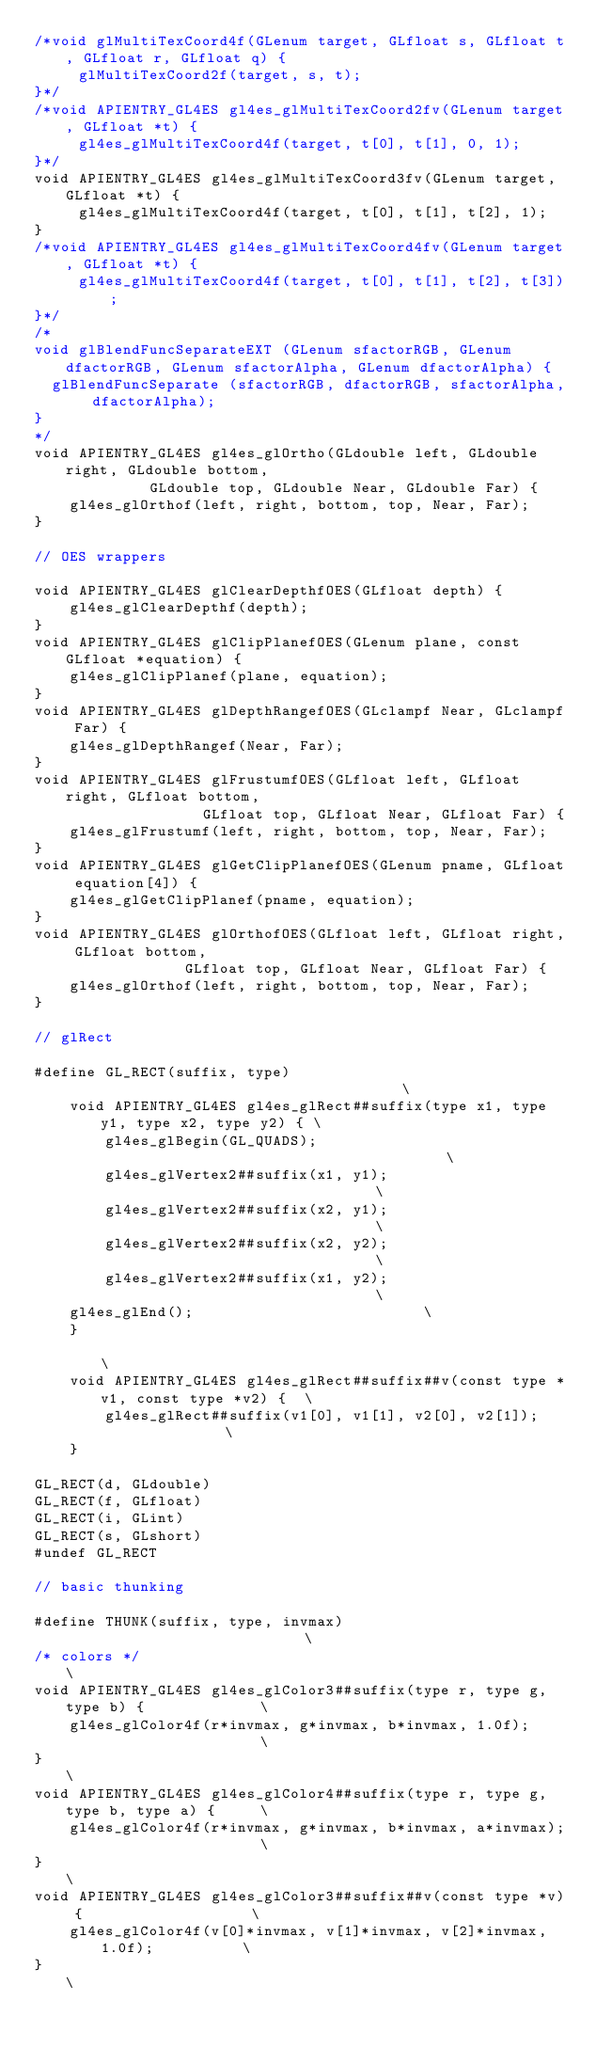<code> <loc_0><loc_0><loc_500><loc_500><_C_>/*void glMultiTexCoord4f(GLenum target, GLfloat s, GLfloat t, GLfloat r, GLfloat q) {
     glMultiTexCoord2f(target, s, t);
}*/
/*void APIENTRY_GL4ES gl4es_glMultiTexCoord2fv(GLenum target, GLfloat *t) {
     gl4es_glMultiTexCoord4f(target, t[0], t[1], 0, 1);
}*/
void APIENTRY_GL4ES gl4es_glMultiTexCoord3fv(GLenum target, GLfloat *t) {
     gl4es_glMultiTexCoord4f(target, t[0], t[1], t[2], 1);
}
/*void APIENTRY_GL4ES gl4es_glMultiTexCoord4fv(GLenum target, GLfloat *t) {
     gl4es_glMultiTexCoord4f(target, t[0], t[1], t[2], t[3]);
}*/
/*
void glBlendFuncSeparateEXT (GLenum sfactorRGB, GLenum dfactorRGB, GLenum sfactorAlpha, GLenum dfactorAlpha) {
	glBlendFuncSeparate (sfactorRGB, dfactorRGB, sfactorAlpha, dfactorAlpha);
}
*/
void APIENTRY_GL4ES gl4es_glOrtho(GLdouble left, GLdouble right, GLdouble bottom,
             GLdouble top, GLdouble Near, GLdouble Far) {
    gl4es_glOrthof(left, right, bottom, top, Near, Far);
}

// OES wrappers

void APIENTRY_GL4ES glClearDepthfOES(GLfloat depth) {
    gl4es_glClearDepthf(depth);
}
void APIENTRY_GL4ES glClipPlanefOES(GLenum plane, const GLfloat *equation) {
    gl4es_glClipPlanef(plane, equation);
}
void APIENTRY_GL4ES glDepthRangefOES(GLclampf Near, GLclampf Far) {
    gl4es_glDepthRangef(Near, Far);
}
void APIENTRY_GL4ES glFrustumfOES(GLfloat left, GLfloat right, GLfloat bottom,
                   GLfloat top, GLfloat Near, GLfloat Far) {
    gl4es_glFrustumf(left, right, bottom, top, Near, Far);
}
void APIENTRY_GL4ES glGetClipPlanefOES(GLenum pname, GLfloat equation[4]) {
    gl4es_glGetClipPlanef(pname, equation);
}
void APIENTRY_GL4ES glOrthofOES(GLfloat left, GLfloat right, GLfloat bottom,
                 GLfloat top, GLfloat Near, GLfloat Far) {
    gl4es_glOrthof(left, right, bottom, top, Near, Far);
}

// glRect

#define GL_RECT(suffix, type)                                       \
    void APIENTRY_GL4ES gl4es_glRect##suffix(type x1, type y1, type x2, type y2) { \
        gl4es_glBegin(GL_QUADS);                                    \
        gl4es_glVertex2##suffix(x1, y1);                            \
        gl4es_glVertex2##suffix(x2, y1);                            \
        gl4es_glVertex2##suffix(x2, y2);                            \
        gl4es_glVertex2##suffix(x1, y2);                            \
		gl4es_glEnd();											    \
    }                                                               \
    void APIENTRY_GL4ES gl4es_glRect##suffix##v(const type *v1, const type *v2) {  \
        gl4es_glRect##suffix(v1[0], v1[1], v2[0], v2[1]);           \
    }

GL_RECT(d, GLdouble)
GL_RECT(f, GLfloat)
GL_RECT(i, GLint)
GL_RECT(s, GLshort)
#undef GL_RECT

// basic thunking

#define THUNK(suffix, type, invmax)                            \
/* colors */                                                \
void APIENTRY_GL4ES gl4es_glColor3##suffix(type r, type g, type b) {             \
    gl4es_glColor4f(r*invmax, g*invmax, b*invmax, 1.0f);                   \
}                                                           \
void APIENTRY_GL4ES gl4es_glColor4##suffix(type r, type g, type b, type a) {     \
    gl4es_glColor4f(r*invmax, g*invmax, b*invmax, a*invmax);                  \
}                                                           \
void APIENTRY_GL4ES gl4es_glColor3##suffix##v(const type *v) {                   \
    gl4es_glColor4f(v[0]*invmax, v[1]*invmax, v[2]*invmax, 1.0f);          \
}                                                           \</code> 